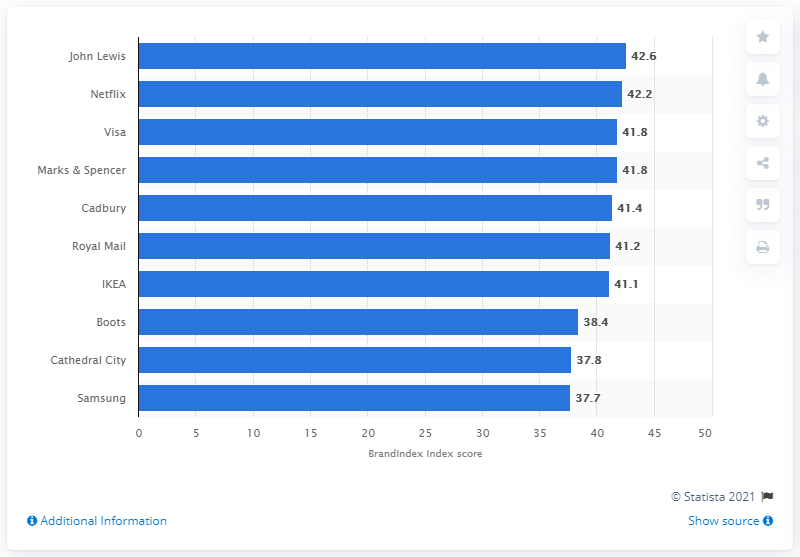List a handful of essential elements in this visual. John Lewis was the leading brand across all industries in the UK during the period of October 2019 and September 2020. The BrandIndex score of John Lewis was 42.6. 